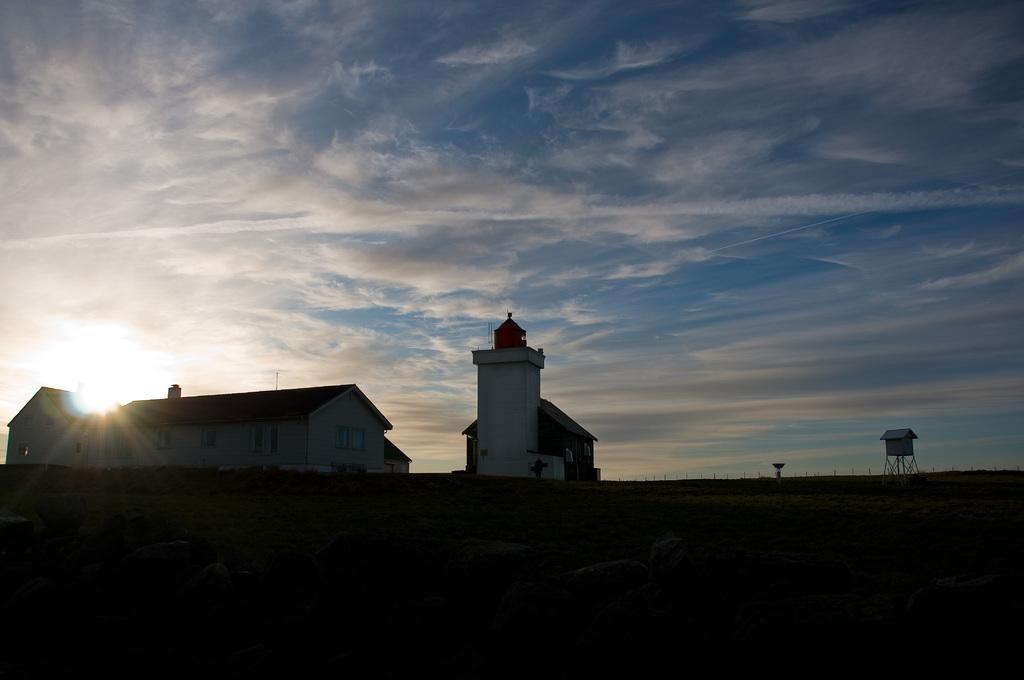Describe this image in one or two sentences. In the center of the image we can see a tower and their sheds. In the background there is sky. 